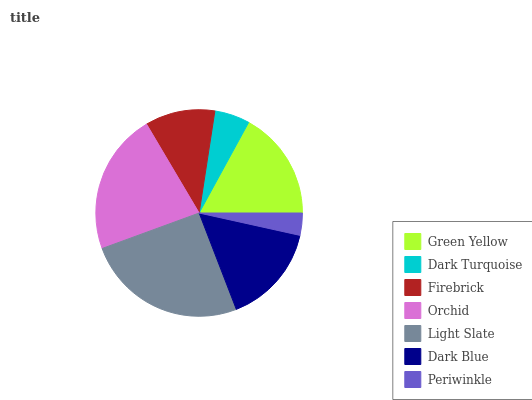Is Periwinkle the minimum?
Answer yes or no. Yes. Is Light Slate the maximum?
Answer yes or no. Yes. Is Dark Turquoise the minimum?
Answer yes or no. No. Is Dark Turquoise the maximum?
Answer yes or no. No. Is Green Yellow greater than Dark Turquoise?
Answer yes or no. Yes. Is Dark Turquoise less than Green Yellow?
Answer yes or no. Yes. Is Dark Turquoise greater than Green Yellow?
Answer yes or no. No. Is Green Yellow less than Dark Turquoise?
Answer yes or no. No. Is Dark Blue the high median?
Answer yes or no. Yes. Is Dark Blue the low median?
Answer yes or no. Yes. Is Periwinkle the high median?
Answer yes or no. No. Is Firebrick the low median?
Answer yes or no. No. 